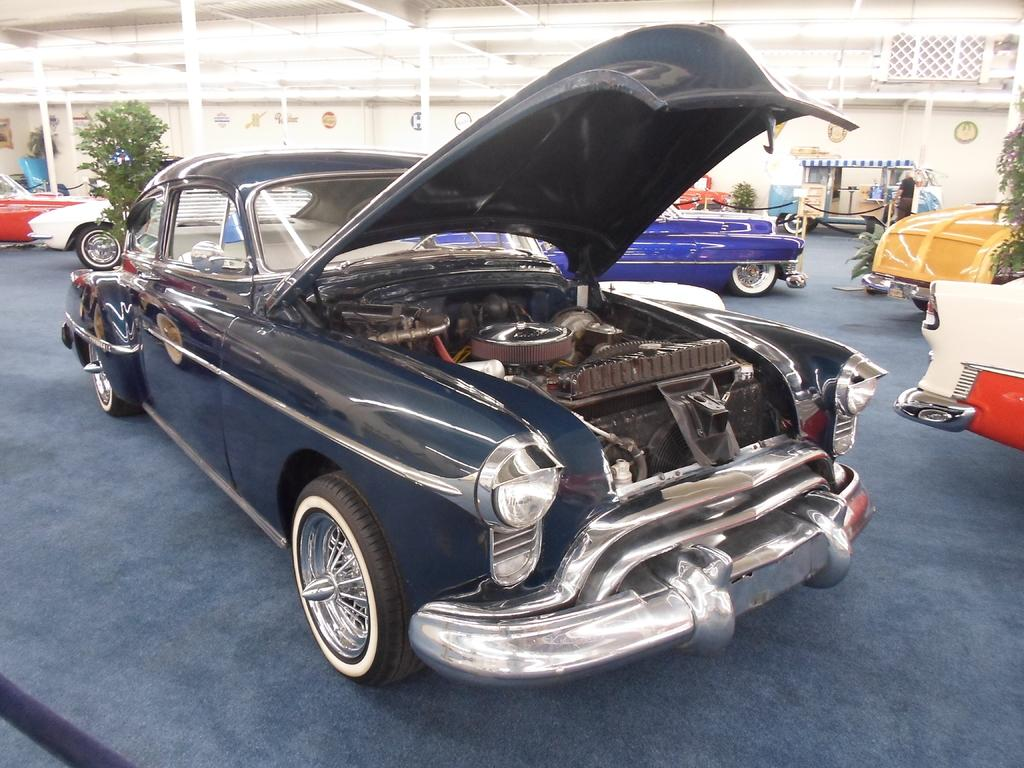What type of vehicles are in the image? There are colorful cars in the image. What color is the path in the image? The path in the image is blue. What type of natural elements are in the image? There are plants in the image. What can be seen in the background of the image? There is a wall visible in the background of the image. Can you see any combs in the image? There are no combs present in the image. Is the image set in space? The image does not depict a space setting; it features colorful cars, a blue path, plants, and a wall in the background. 